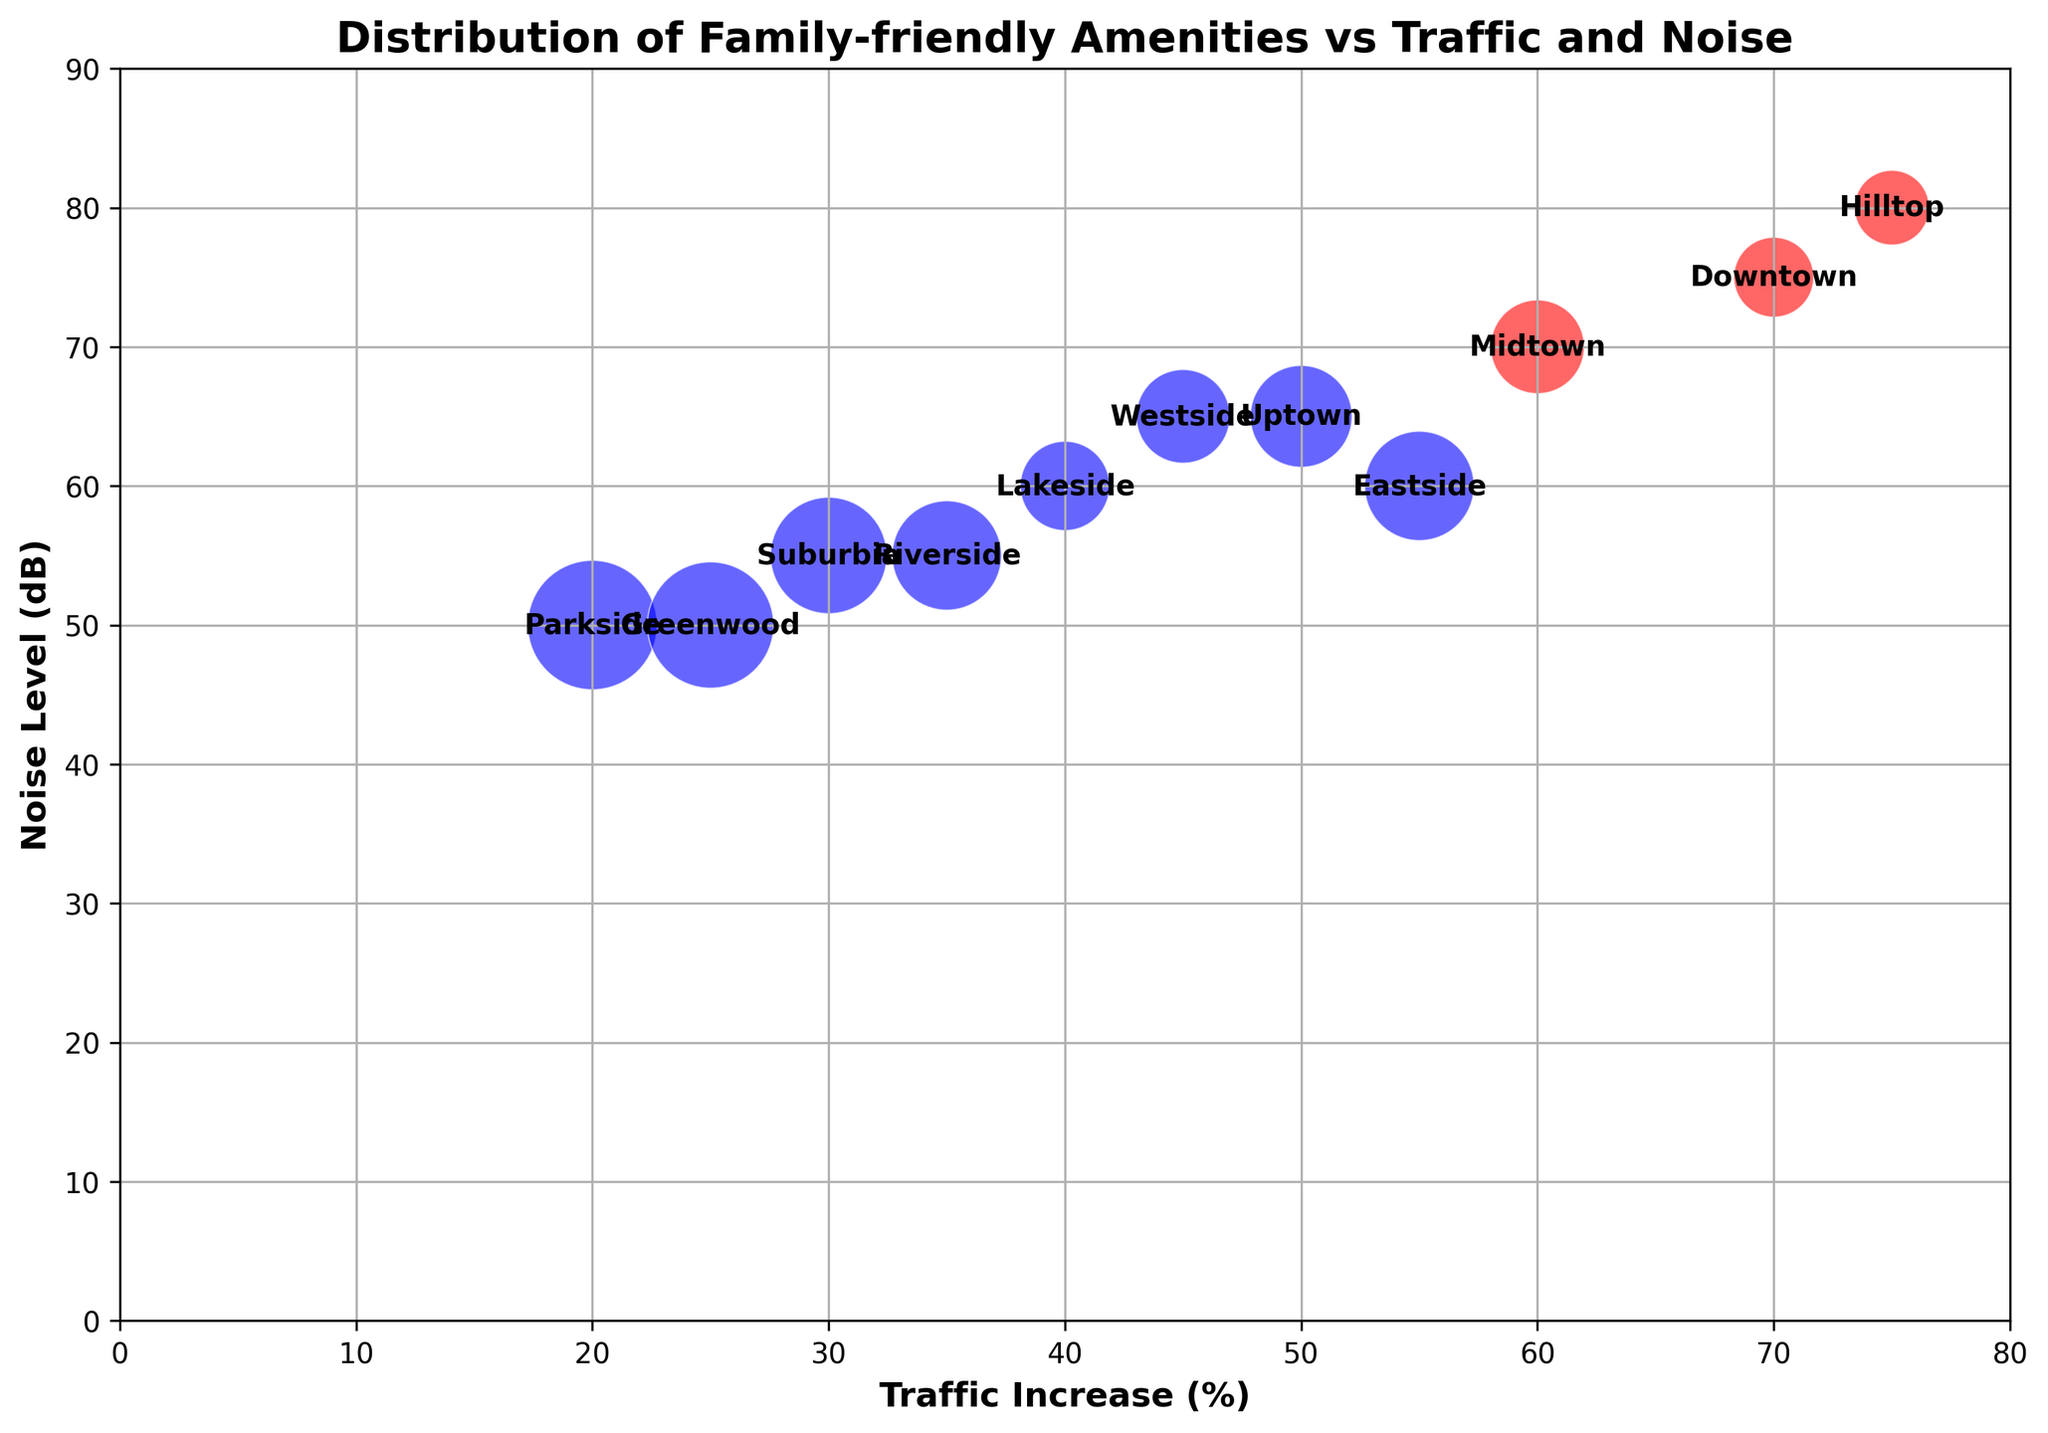What neighborhood has the highest traffic increase? Look for the point on the x-axis farthest to the right, which represents the highest traffic increase. The point at (75, 80) represents Hilltop.
Answer: Hilltop What is the relationship between traffic increase and noise level in Parkside? Find the point labeled Parkside and note its coordinates. Parkside is at (20, 50), indicating a lower traffic increase and noise level.
Answer: Lower traffic increase and noise level Which neighborhood has the largest bubble size? Bubble size represents the sum of parks, schools, and hospitals. Identify the largest bubble visually. Greenwood and Parkside have large bubbles, but Parkside is the largest due to its highest sum of amenities.
Answer: Parkside How do traffic increase and noise level correlate in Downtown compared to Hilltop? Compare the points from Downtown (70, 75) and Hilltop (75, 80), noting that both have high traffic and noise, but Hilltop is slightly higher in both aspects.
Answer: Hilltop is higher in both Which neighborhood has the most amenities but low traffic increase and noise level? Look for the biggest bubble with the lowest traffic and noise coordinates. Parkside has the most amenities with coordinates (20, 50).
Answer: Parkside How many neighborhoods have a traffic increase of less than 30%? Count the points on the x-axis where the traffic increase is less than 30. Only Suburbia (30) and Parkside (20) fit this criterion.
Answer: 2 neighborhoods Are there any neighborhoods with low traffic but high noise levels? Identify points with low x-axis (traffic) but high y-axis (noise). All neighborhoods with low traffic, such as Parkside (20, 50) and Greenwood (25, 50), have corresponding low noise.
Answer: No What characteristics stand out for Uptown's traffic increase and amenities? Note Uptown (50, 65) and its bubble size. Uptown has a moderate traffic increase and noise level, with a moderate number of amenities.
Answer: Moderate traffic, noise, and amenities Which neighborhoods have both high traffic and noise levels? Identify points where both x and y coordinates are high. Downtown (70, 75) and Hilltop (75, 80) fit this description.
Answer: Downtown and Hilltop What colors represent high vs. low product of traffic and noise? Note the color coding: red for high values and blue for lower values. Then, observe the colors on the plotted points. Red represents a higher product of traffic and noise (>4000), while blue represents lower.
Answer: Red for high, blue for low 